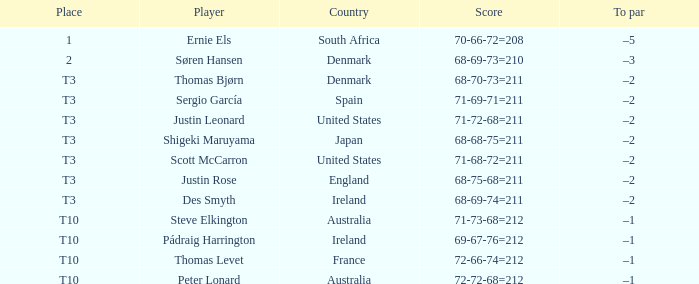What was the position when the score was 68-75-68=211? T3. 